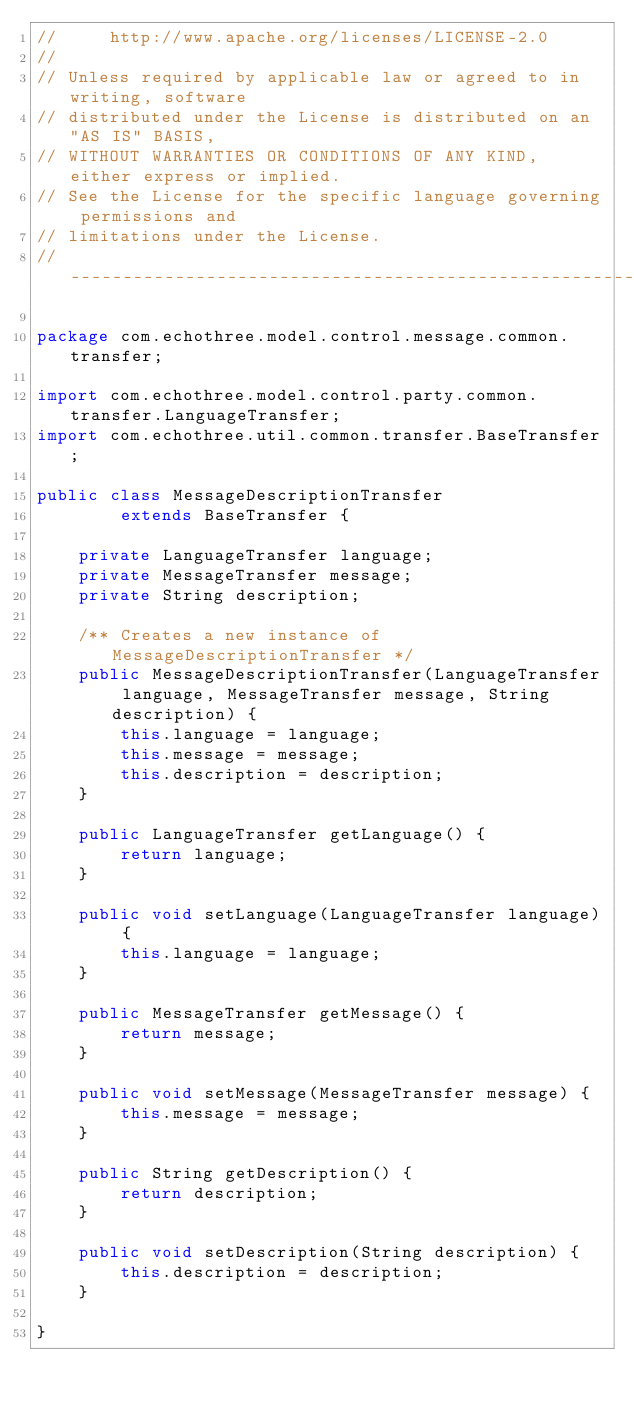<code> <loc_0><loc_0><loc_500><loc_500><_Java_>//     http://www.apache.org/licenses/LICENSE-2.0
//
// Unless required by applicable law or agreed to in writing, software
// distributed under the License is distributed on an "AS IS" BASIS,
// WITHOUT WARRANTIES OR CONDITIONS OF ANY KIND, either express or implied.
// See the License for the specific language governing permissions and
// limitations under the License.
// --------------------------------------------------------------------------------

package com.echothree.model.control.message.common.transfer;

import com.echothree.model.control.party.common.transfer.LanguageTransfer;
import com.echothree.util.common.transfer.BaseTransfer;

public class MessageDescriptionTransfer
        extends BaseTransfer {
    
    private LanguageTransfer language;
    private MessageTransfer message;
    private String description;
    
    /** Creates a new instance of MessageDescriptionTransfer */
    public MessageDescriptionTransfer(LanguageTransfer language, MessageTransfer message, String description) {
        this.language = language;
        this.message = message;
        this.description = description;
    }
    
    public LanguageTransfer getLanguage() {
        return language;
    }
    
    public void setLanguage(LanguageTransfer language) {
        this.language = language;
    }
    
    public MessageTransfer getMessage() {
        return message;
    }
    
    public void setMessage(MessageTransfer message) {
        this.message = message;
    }
    
    public String getDescription() {
        return description;
    }
    
    public void setDescription(String description) {
        this.description = description;
    }
    
}
</code> 